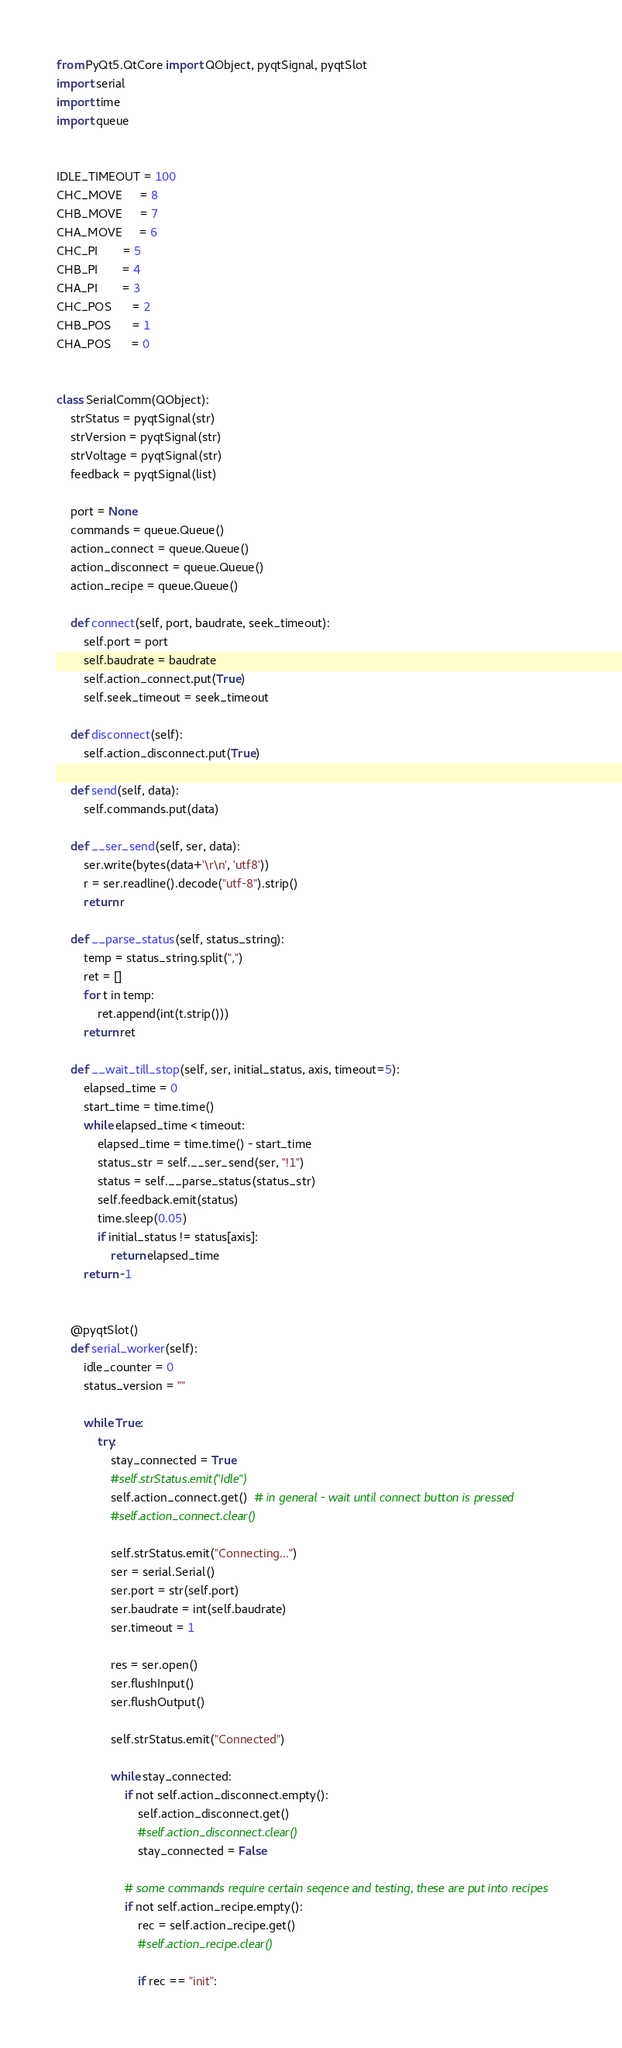<code> <loc_0><loc_0><loc_500><loc_500><_Python_>from PyQt5.QtCore import QObject, pyqtSignal, pyqtSlot
import serial
import time
import queue


IDLE_TIMEOUT = 100
CHC_MOVE     = 8
CHB_MOVE     = 7
CHA_MOVE     = 6
CHC_PI       = 5
CHB_PI       = 4
CHA_PI       = 3
CHC_POS      = 2
CHB_POS      = 1
CHA_POS      = 0


class SerialComm(QObject):
    strStatus = pyqtSignal(str)
    strVersion = pyqtSignal(str)
    strVoltage = pyqtSignal(str)
    feedback = pyqtSignal(list)

    port = None
    commands = queue.Queue()
    action_connect = queue.Queue()
    action_disconnect = queue.Queue()
    action_recipe = queue.Queue()

    def connect(self, port, baudrate, seek_timeout):
        self.port = port
        self.baudrate = baudrate
        self.action_connect.put(True)
        self.seek_timeout = seek_timeout

    def disconnect(self):
        self.action_disconnect.put(True)

    def send(self, data):
        self.commands.put(data)

    def __ser_send(self, ser, data):
        ser.write(bytes(data+'\r\n', 'utf8'))
        r = ser.readline().decode("utf-8").strip()
        return r

    def __parse_status(self, status_string):
        temp = status_string.split(",")
        ret = []
        for t in temp:
            ret.append(int(t.strip()))
        return ret

    def __wait_till_stop(self, ser, initial_status, axis, timeout=5):
        elapsed_time = 0
        start_time = time.time()
        while elapsed_time < timeout:
            elapsed_time = time.time() - start_time
            status_str = self.__ser_send(ser, "!1")
            status = self.__parse_status(status_str)
            self.feedback.emit(status)
            time.sleep(0.05)
            if initial_status != status[axis]:
                return elapsed_time
        return -1


    @pyqtSlot()
    def serial_worker(self):
        idle_counter = 0
        status_version = ""

        while True:
            try:
                stay_connected = True
                #self.strStatus.emit("Idle")
                self.action_connect.get()  # in general - wait until connect button is pressed
                #self.action_connect.clear()

                self.strStatus.emit("Connecting...")
                ser = serial.Serial()
                ser.port = str(self.port)
                ser.baudrate = int(self.baudrate)
                ser.timeout = 1

                res = ser.open()
                ser.flushInput()
                ser.flushOutput()

                self.strStatus.emit("Connected")

                while stay_connected:
                    if not self.action_disconnect.empty():
                        self.action_disconnect.get()
                        #self.action_disconnect.clear()
                        stay_connected = False

                    # some commands require certain seqence and testing, these are put into recipes
                    if not self.action_recipe.empty():
                        rec = self.action_recipe.get()
                        #self.action_recipe.clear()

                        if rec == "init":</code> 